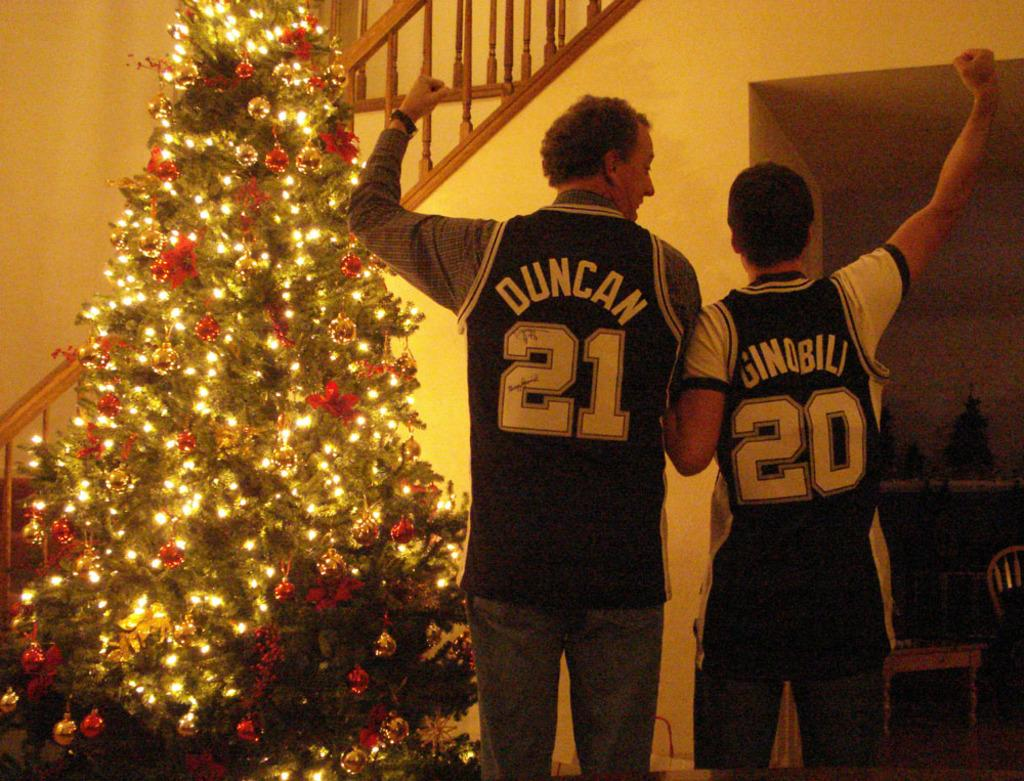Provide a one-sentence caption for the provided image. Two men wearing basketball jerseys numbered 21 and 20 celebrate in front of a Christmas tree. 